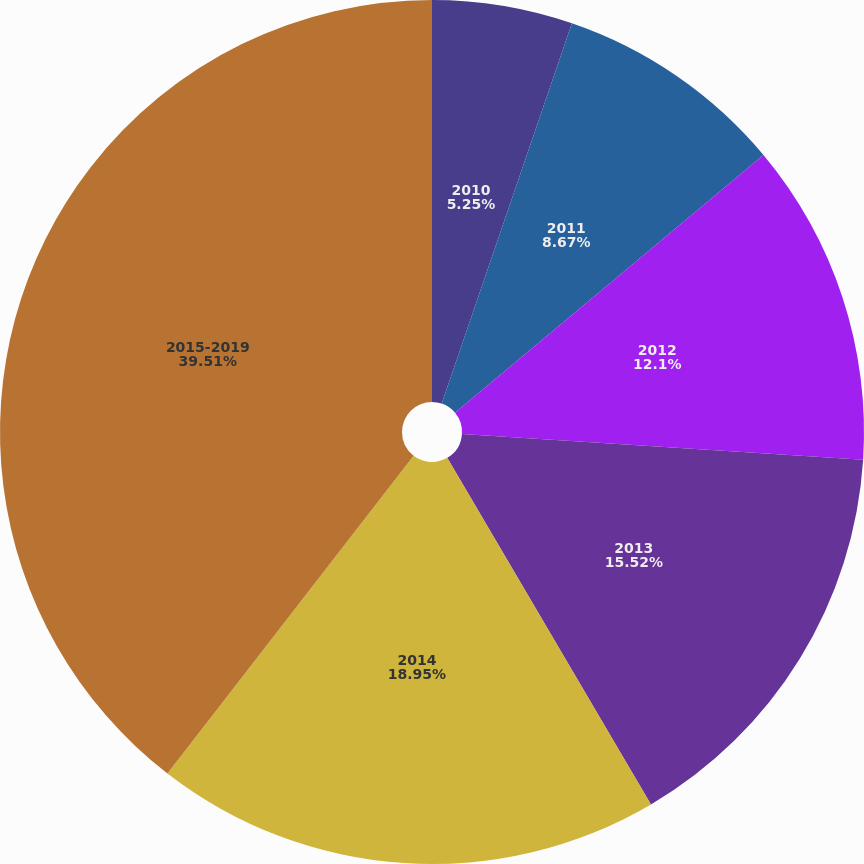<chart> <loc_0><loc_0><loc_500><loc_500><pie_chart><fcel>2010<fcel>2011<fcel>2012<fcel>2013<fcel>2014<fcel>2015-2019<nl><fcel>5.25%<fcel>8.67%<fcel>12.1%<fcel>15.52%<fcel>18.95%<fcel>39.51%<nl></chart> 